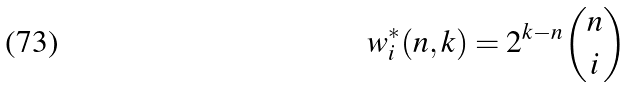Convert formula to latex. <formula><loc_0><loc_0><loc_500><loc_500>w ^ { * } _ { i } ( n , k ) = 2 ^ { k - n } \binom { n } { i }</formula> 